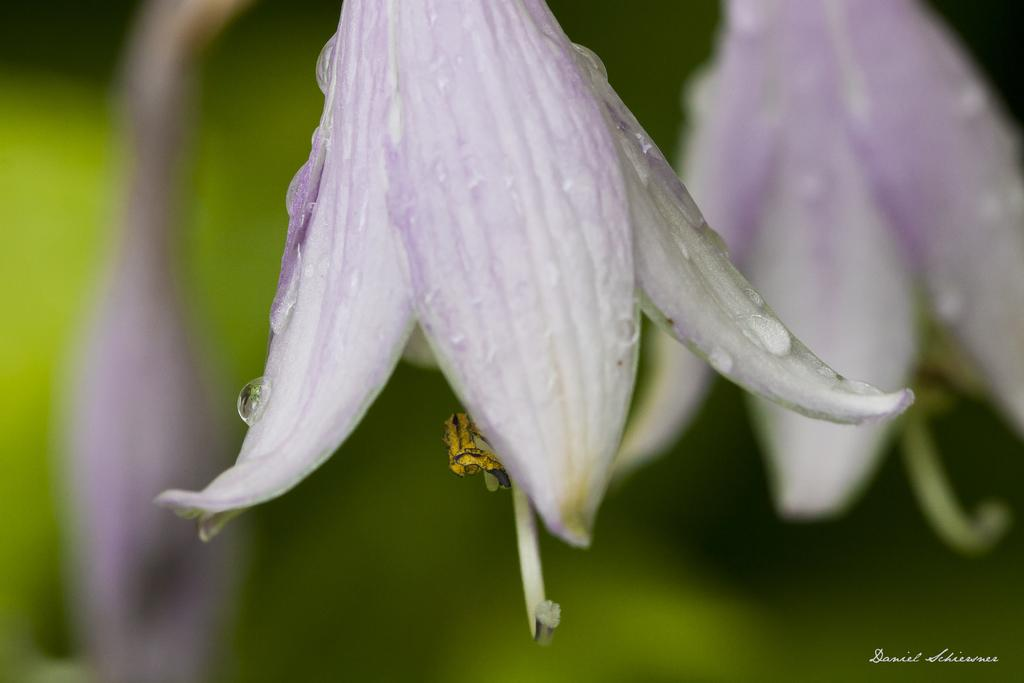What is located in the front of the image? There are flowers in the front of the image. Can you describe the background of the image? The background of the image is blurred. What type of powder is sprinkled on top of the flowers in the image? There is no powder visible on top of the flowers in the image. Who is the creator of the flowers in the image? The image does not provide information about the creator of the flowers. 